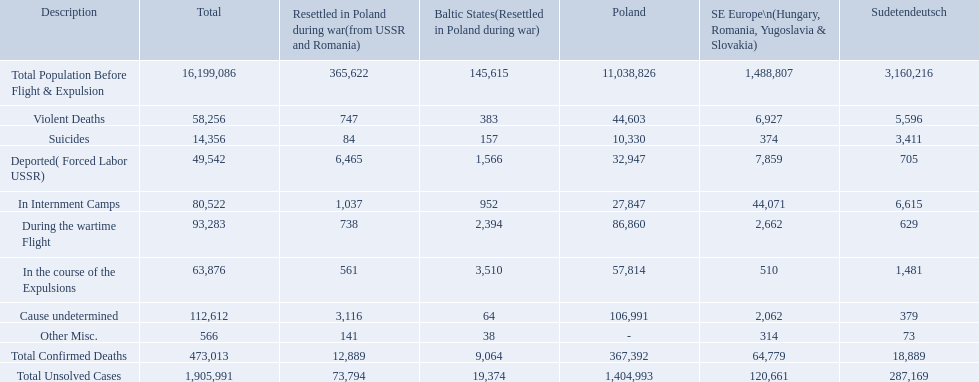How many deaths did the baltic states have in each category? 145,615, 383, 157, 1,566, 952, 2,394, 3,510, 64, 38, 9,064, 19,374. How many cause undetermined deaths did baltic states have? 64. How many other miscellaneous deaths did baltic states have? 38. Which is higher in deaths, cause undetermined or other miscellaneous? Cause undetermined. 